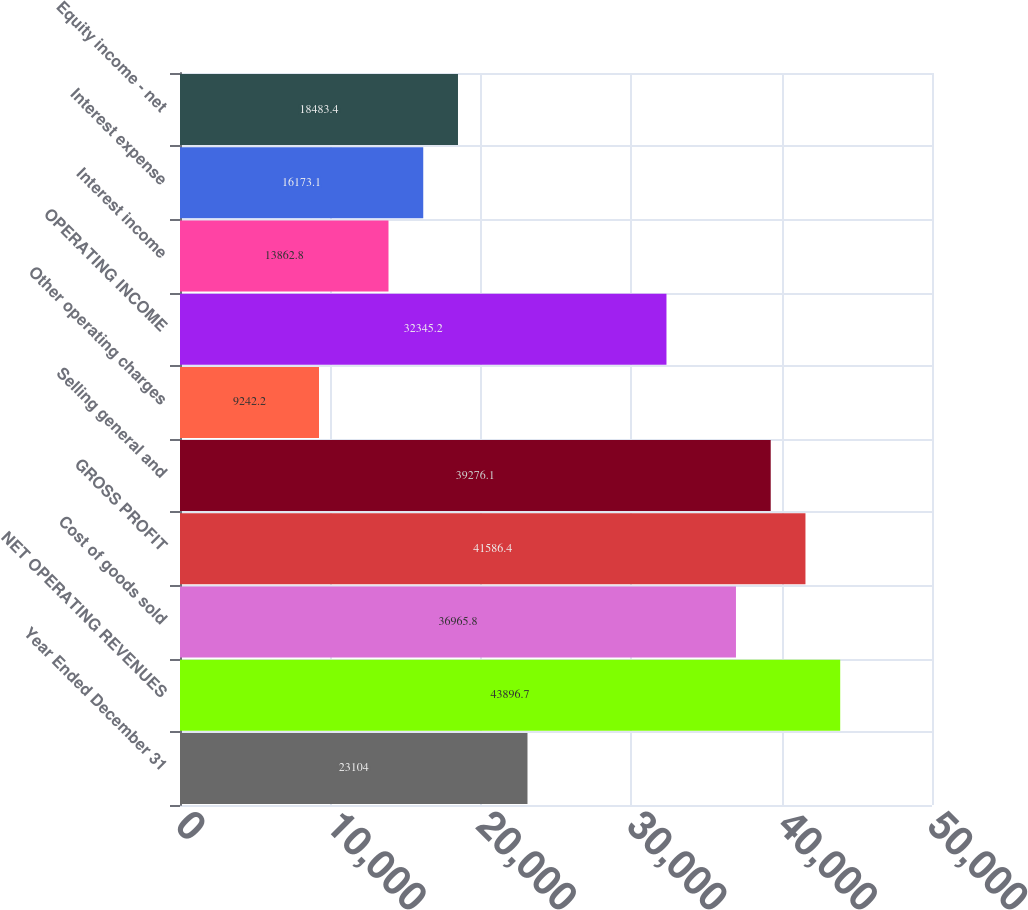<chart> <loc_0><loc_0><loc_500><loc_500><bar_chart><fcel>Year Ended December 31<fcel>NET OPERATING REVENUES<fcel>Cost of goods sold<fcel>GROSS PROFIT<fcel>Selling general and<fcel>Other operating charges<fcel>OPERATING INCOME<fcel>Interest income<fcel>Interest expense<fcel>Equity income - net<nl><fcel>23104<fcel>43896.7<fcel>36965.8<fcel>41586.4<fcel>39276.1<fcel>9242.2<fcel>32345.2<fcel>13862.8<fcel>16173.1<fcel>18483.4<nl></chart> 